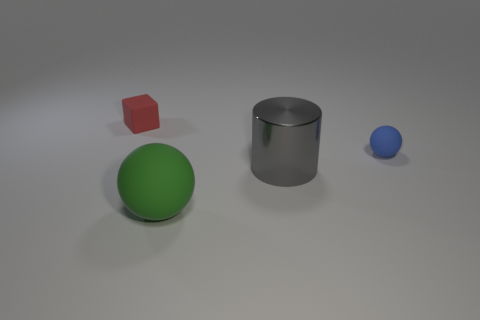How many gray metallic cylinders have the same size as the green thing?
Your response must be concise. 1. What is the color of the rubber thing that is behind the green object and in front of the block?
Make the answer very short. Blue. Is the number of tiny shiny cylinders less than the number of gray things?
Your answer should be very brief. Yes. Is the color of the cube the same as the tiny thing that is to the right of the tiny matte cube?
Your answer should be very brief. No. Are there an equal number of tiny rubber things that are right of the big ball and large metal cylinders that are in front of the gray shiny thing?
Provide a succinct answer. No. What number of tiny red rubber things have the same shape as the small blue matte thing?
Ensure brevity in your answer.  0. Is there a small purple matte cube?
Your response must be concise. No. Is the material of the red object the same as the object on the right side of the large shiny cylinder?
Keep it short and to the point. Yes. There is a blue thing that is the same size as the cube; what is its material?
Provide a short and direct response. Rubber. Is there a tiny gray sphere that has the same material as the small red cube?
Provide a succinct answer. No. 